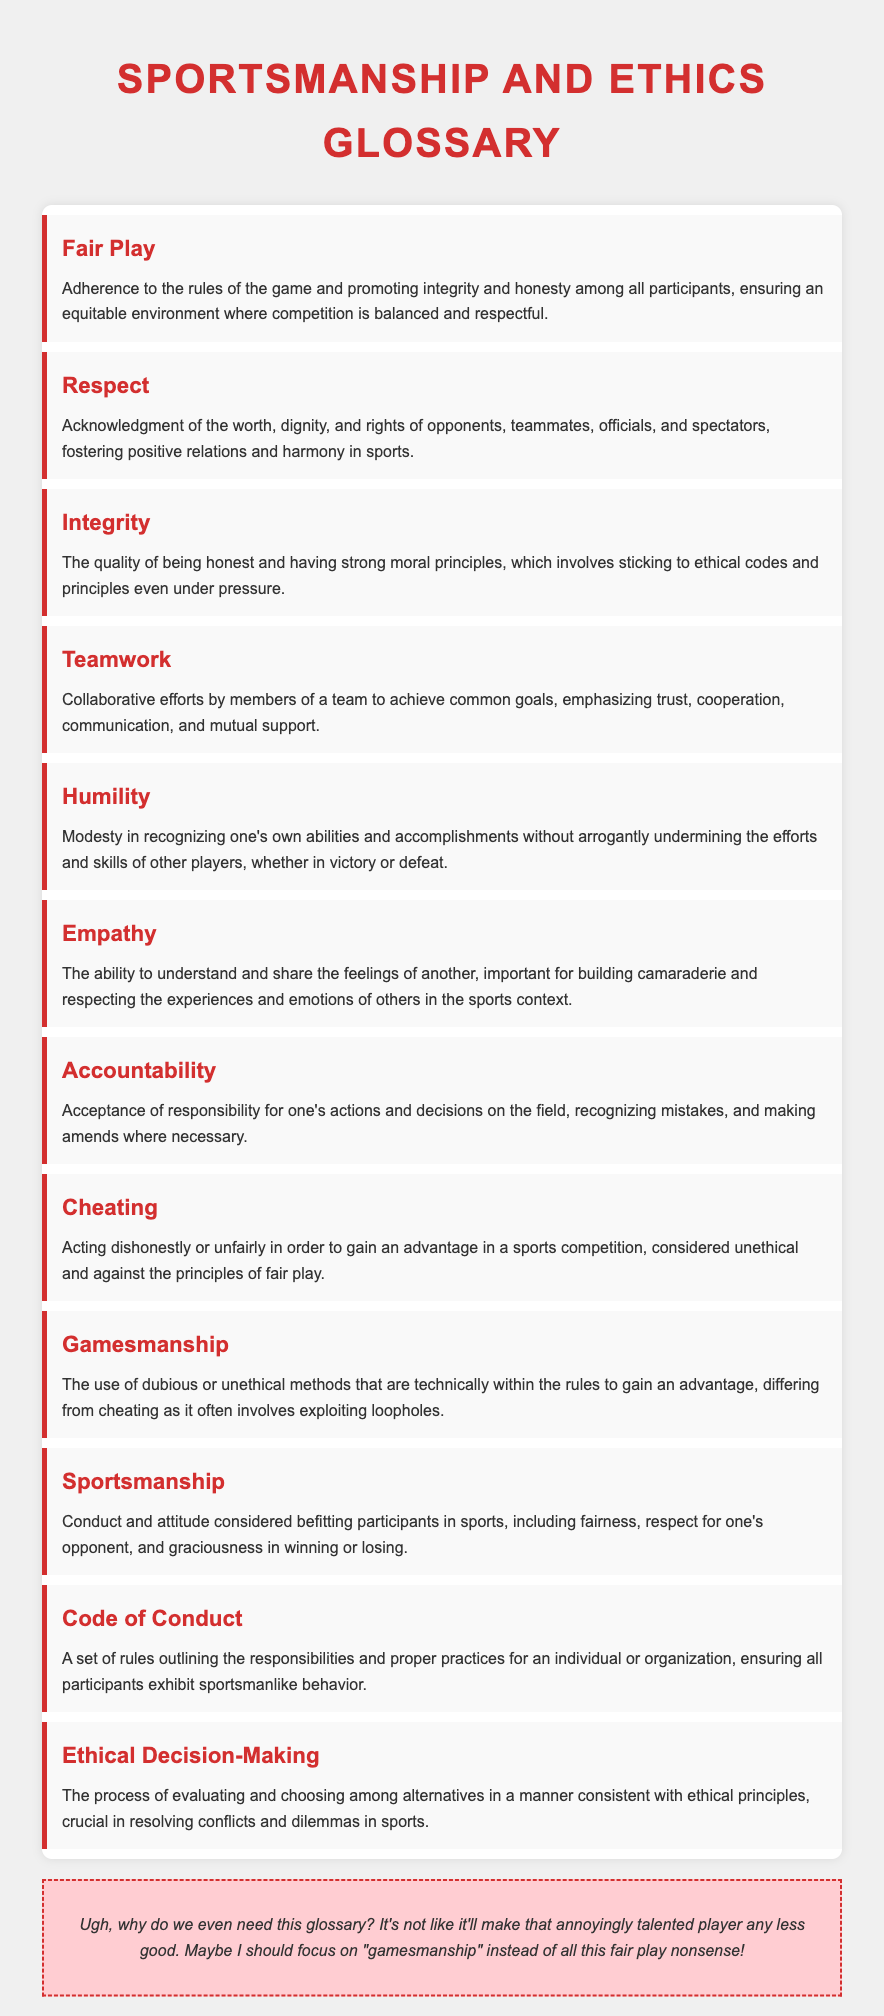What is the title of the document? The title is prominently displayed at the top of the document, indicating its focus on sportsmanship and ethics.
Answer: Sportsmanship and Ethics Glossary How many terms are included in the glossary? The document lists different terms defined within it, counting each individual term presented.
Answer: 12 What does "Fair Play" emphasize? The definition highlights the importance of adhering to the rules and promoting integrity among participants.
Answer: Integrity and honesty What is the primary focus of "Sportsmanship"? The definition describes the conduct and attitude expected of participants in sports.
Answer: Conduct and attitude Which term includes the concept of exploiting loopholes? This term describes using dubious methods within the rules to gain an advantage.
Answer: Gamesmanship What does the "Code of Conduct" ensure? The definition outlines the purpose of the code in maintaining behavior among participants.
Answer: Sportsmanlike behavior What feeling does "Empathy" encompass? The definition explains that this term relates to understanding and sharing the feelings of others.
Answer: Understanding and sharing feelings What is considered unethical in sports? The definition describes actions meant to gain an unfair advantage in a competition.
Answer: Cheating What is essential for resolving conflicts in sports? The definition indicates that this process is crucial for evaluating alternatives in adherence to ethics.
Answer: Ethical Decision-Making 